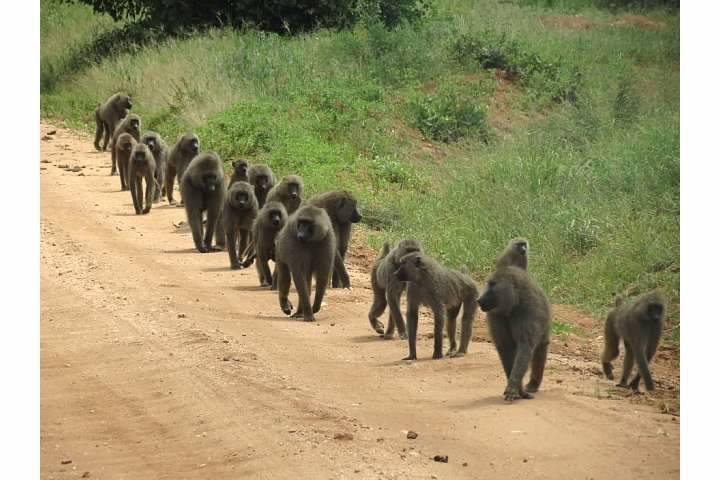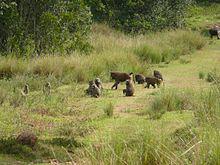The first image is the image on the left, the second image is the image on the right. Evaluate the accuracy of this statement regarding the images: "Several primates are situated on a dirt roadway.". Is it true? Answer yes or no. Yes. The first image is the image on the left, the second image is the image on the right. Examine the images to the left and right. Is the description "An image shows baboons on a dirt path flanked by greenery." accurate? Answer yes or no. Yes. 